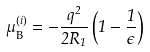<formula> <loc_0><loc_0><loc_500><loc_500>\mu _ { \text {B} } ^ { ( i ) } = - \frac { q ^ { 2 } } { 2 R _ { 1 } } \left ( 1 - \frac { 1 } { \epsilon } \right )</formula> 